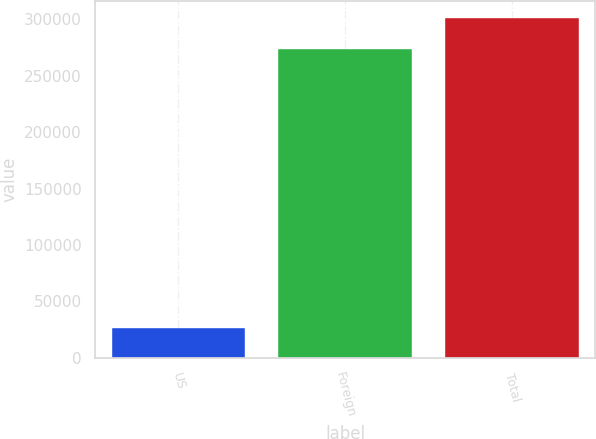Convert chart to OTSL. <chart><loc_0><loc_0><loc_500><loc_500><bar_chart><fcel>US<fcel>Foreign<fcel>Total<nl><fcel>26888<fcel>273805<fcel>301186<nl></chart> 